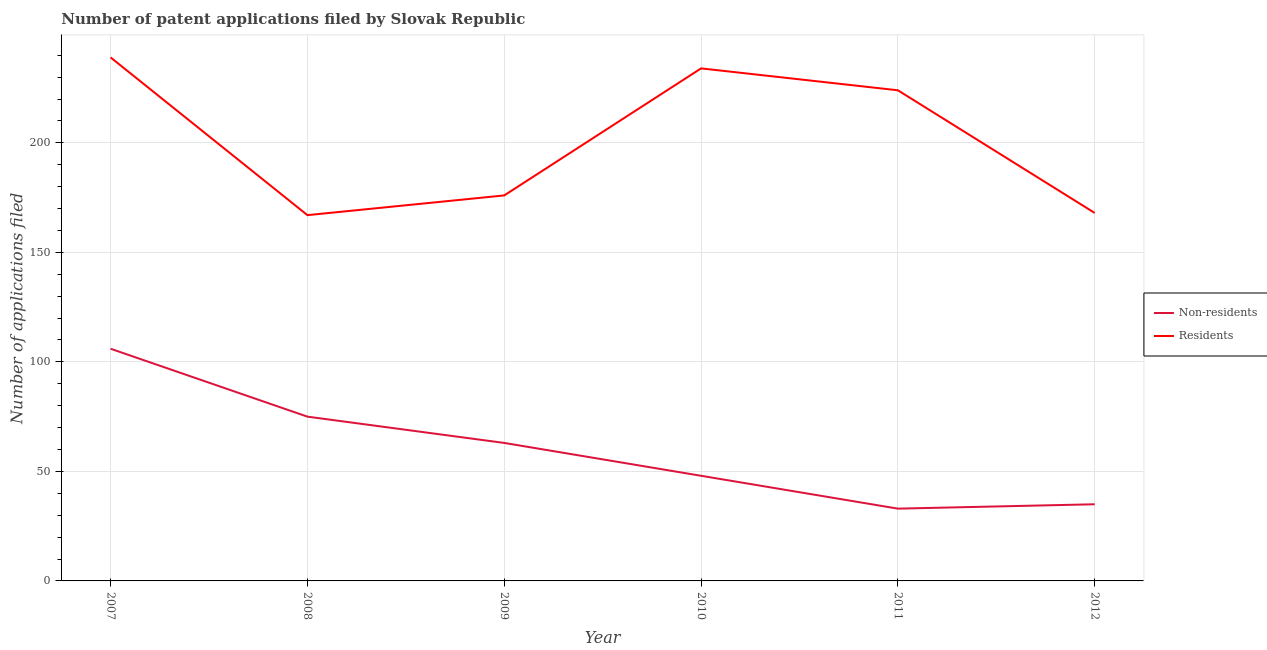Does the line corresponding to number of patent applications by non residents intersect with the line corresponding to number of patent applications by residents?
Your answer should be very brief. No. What is the number of patent applications by non residents in 2010?
Keep it short and to the point. 48. Across all years, what is the maximum number of patent applications by non residents?
Your answer should be compact. 106. Across all years, what is the minimum number of patent applications by non residents?
Offer a terse response. 33. In which year was the number of patent applications by residents maximum?
Give a very brief answer. 2007. What is the total number of patent applications by non residents in the graph?
Your answer should be compact. 360. What is the difference between the number of patent applications by residents in 2008 and that in 2011?
Make the answer very short. -57. What is the difference between the number of patent applications by residents in 2008 and the number of patent applications by non residents in 2007?
Your response must be concise. 61. What is the average number of patent applications by residents per year?
Your answer should be compact. 201.33. In the year 2007, what is the difference between the number of patent applications by non residents and number of patent applications by residents?
Ensure brevity in your answer.  -133. In how many years, is the number of patent applications by non residents greater than 30?
Offer a terse response. 6. What is the ratio of the number of patent applications by residents in 2009 to that in 2011?
Make the answer very short. 0.79. Is the number of patent applications by residents in 2010 less than that in 2011?
Your answer should be very brief. No. Is the difference between the number of patent applications by residents in 2011 and 2012 greater than the difference between the number of patent applications by non residents in 2011 and 2012?
Ensure brevity in your answer.  Yes. What is the difference between the highest and the lowest number of patent applications by non residents?
Give a very brief answer. 73. In how many years, is the number of patent applications by non residents greater than the average number of patent applications by non residents taken over all years?
Offer a very short reply. 3. Is the sum of the number of patent applications by residents in 2007 and 2008 greater than the maximum number of patent applications by non residents across all years?
Provide a succinct answer. Yes. How many lines are there?
Offer a terse response. 2. How many years are there in the graph?
Your response must be concise. 6. What is the difference between two consecutive major ticks on the Y-axis?
Make the answer very short. 50. Does the graph contain any zero values?
Your answer should be compact. No. Does the graph contain grids?
Offer a terse response. Yes. How are the legend labels stacked?
Offer a very short reply. Vertical. What is the title of the graph?
Make the answer very short. Number of patent applications filed by Slovak Republic. Does "Transport services" appear as one of the legend labels in the graph?
Offer a very short reply. No. What is the label or title of the X-axis?
Provide a succinct answer. Year. What is the label or title of the Y-axis?
Your answer should be compact. Number of applications filed. What is the Number of applications filed of Non-residents in 2007?
Your answer should be compact. 106. What is the Number of applications filed of Residents in 2007?
Provide a succinct answer. 239. What is the Number of applications filed in Residents in 2008?
Offer a terse response. 167. What is the Number of applications filed of Non-residents in 2009?
Make the answer very short. 63. What is the Number of applications filed of Residents in 2009?
Your response must be concise. 176. What is the Number of applications filed of Non-residents in 2010?
Your answer should be compact. 48. What is the Number of applications filed in Residents in 2010?
Ensure brevity in your answer.  234. What is the Number of applications filed in Residents in 2011?
Make the answer very short. 224. What is the Number of applications filed in Non-residents in 2012?
Give a very brief answer. 35. What is the Number of applications filed of Residents in 2012?
Ensure brevity in your answer.  168. Across all years, what is the maximum Number of applications filed of Non-residents?
Your answer should be very brief. 106. Across all years, what is the maximum Number of applications filed in Residents?
Make the answer very short. 239. Across all years, what is the minimum Number of applications filed of Residents?
Offer a terse response. 167. What is the total Number of applications filed in Non-residents in the graph?
Give a very brief answer. 360. What is the total Number of applications filed of Residents in the graph?
Offer a very short reply. 1208. What is the difference between the Number of applications filed in Residents in 2007 and that in 2008?
Provide a short and direct response. 72. What is the difference between the Number of applications filed of Residents in 2007 and that in 2009?
Give a very brief answer. 63. What is the difference between the Number of applications filed of Non-residents in 2007 and that in 2012?
Offer a very short reply. 71. What is the difference between the Number of applications filed in Residents in 2007 and that in 2012?
Ensure brevity in your answer.  71. What is the difference between the Number of applications filed in Non-residents in 2008 and that in 2009?
Give a very brief answer. 12. What is the difference between the Number of applications filed of Residents in 2008 and that in 2010?
Make the answer very short. -67. What is the difference between the Number of applications filed of Non-residents in 2008 and that in 2011?
Your response must be concise. 42. What is the difference between the Number of applications filed in Residents in 2008 and that in 2011?
Offer a terse response. -57. What is the difference between the Number of applications filed of Residents in 2009 and that in 2010?
Offer a very short reply. -58. What is the difference between the Number of applications filed in Residents in 2009 and that in 2011?
Ensure brevity in your answer.  -48. What is the difference between the Number of applications filed in Residents in 2010 and that in 2011?
Keep it short and to the point. 10. What is the difference between the Number of applications filed in Non-residents in 2011 and that in 2012?
Offer a terse response. -2. What is the difference between the Number of applications filed of Residents in 2011 and that in 2012?
Ensure brevity in your answer.  56. What is the difference between the Number of applications filed of Non-residents in 2007 and the Number of applications filed of Residents in 2008?
Your answer should be compact. -61. What is the difference between the Number of applications filed of Non-residents in 2007 and the Number of applications filed of Residents in 2009?
Provide a succinct answer. -70. What is the difference between the Number of applications filed in Non-residents in 2007 and the Number of applications filed in Residents in 2010?
Provide a short and direct response. -128. What is the difference between the Number of applications filed of Non-residents in 2007 and the Number of applications filed of Residents in 2011?
Give a very brief answer. -118. What is the difference between the Number of applications filed in Non-residents in 2007 and the Number of applications filed in Residents in 2012?
Your answer should be compact. -62. What is the difference between the Number of applications filed in Non-residents in 2008 and the Number of applications filed in Residents in 2009?
Your answer should be compact. -101. What is the difference between the Number of applications filed of Non-residents in 2008 and the Number of applications filed of Residents in 2010?
Offer a terse response. -159. What is the difference between the Number of applications filed in Non-residents in 2008 and the Number of applications filed in Residents in 2011?
Your answer should be compact. -149. What is the difference between the Number of applications filed of Non-residents in 2008 and the Number of applications filed of Residents in 2012?
Offer a very short reply. -93. What is the difference between the Number of applications filed of Non-residents in 2009 and the Number of applications filed of Residents in 2010?
Give a very brief answer. -171. What is the difference between the Number of applications filed of Non-residents in 2009 and the Number of applications filed of Residents in 2011?
Offer a terse response. -161. What is the difference between the Number of applications filed in Non-residents in 2009 and the Number of applications filed in Residents in 2012?
Ensure brevity in your answer.  -105. What is the difference between the Number of applications filed of Non-residents in 2010 and the Number of applications filed of Residents in 2011?
Provide a short and direct response. -176. What is the difference between the Number of applications filed in Non-residents in 2010 and the Number of applications filed in Residents in 2012?
Give a very brief answer. -120. What is the difference between the Number of applications filed in Non-residents in 2011 and the Number of applications filed in Residents in 2012?
Offer a very short reply. -135. What is the average Number of applications filed in Residents per year?
Ensure brevity in your answer.  201.33. In the year 2007, what is the difference between the Number of applications filed of Non-residents and Number of applications filed of Residents?
Provide a short and direct response. -133. In the year 2008, what is the difference between the Number of applications filed of Non-residents and Number of applications filed of Residents?
Your response must be concise. -92. In the year 2009, what is the difference between the Number of applications filed in Non-residents and Number of applications filed in Residents?
Your answer should be very brief. -113. In the year 2010, what is the difference between the Number of applications filed of Non-residents and Number of applications filed of Residents?
Your response must be concise. -186. In the year 2011, what is the difference between the Number of applications filed in Non-residents and Number of applications filed in Residents?
Offer a very short reply. -191. In the year 2012, what is the difference between the Number of applications filed of Non-residents and Number of applications filed of Residents?
Provide a succinct answer. -133. What is the ratio of the Number of applications filed of Non-residents in 2007 to that in 2008?
Make the answer very short. 1.41. What is the ratio of the Number of applications filed in Residents in 2007 to that in 2008?
Offer a terse response. 1.43. What is the ratio of the Number of applications filed of Non-residents in 2007 to that in 2009?
Make the answer very short. 1.68. What is the ratio of the Number of applications filed of Residents in 2007 to that in 2009?
Give a very brief answer. 1.36. What is the ratio of the Number of applications filed in Non-residents in 2007 to that in 2010?
Provide a succinct answer. 2.21. What is the ratio of the Number of applications filed of Residents in 2007 to that in 2010?
Keep it short and to the point. 1.02. What is the ratio of the Number of applications filed in Non-residents in 2007 to that in 2011?
Your answer should be compact. 3.21. What is the ratio of the Number of applications filed of Residents in 2007 to that in 2011?
Provide a succinct answer. 1.07. What is the ratio of the Number of applications filed in Non-residents in 2007 to that in 2012?
Offer a very short reply. 3.03. What is the ratio of the Number of applications filed in Residents in 2007 to that in 2012?
Give a very brief answer. 1.42. What is the ratio of the Number of applications filed in Non-residents in 2008 to that in 2009?
Offer a terse response. 1.19. What is the ratio of the Number of applications filed of Residents in 2008 to that in 2009?
Offer a terse response. 0.95. What is the ratio of the Number of applications filed of Non-residents in 2008 to that in 2010?
Your response must be concise. 1.56. What is the ratio of the Number of applications filed in Residents in 2008 to that in 2010?
Make the answer very short. 0.71. What is the ratio of the Number of applications filed in Non-residents in 2008 to that in 2011?
Provide a succinct answer. 2.27. What is the ratio of the Number of applications filed of Residents in 2008 to that in 2011?
Make the answer very short. 0.75. What is the ratio of the Number of applications filed in Non-residents in 2008 to that in 2012?
Your answer should be compact. 2.14. What is the ratio of the Number of applications filed in Residents in 2008 to that in 2012?
Your answer should be compact. 0.99. What is the ratio of the Number of applications filed in Non-residents in 2009 to that in 2010?
Your answer should be compact. 1.31. What is the ratio of the Number of applications filed in Residents in 2009 to that in 2010?
Provide a short and direct response. 0.75. What is the ratio of the Number of applications filed of Non-residents in 2009 to that in 2011?
Keep it short and to the point. 1.91. What is the ratio of the Number of applications filed of Residents in 2009 to that in 2011?
Keep it short and to the point. 0.79. What is the ratio of the Number of applications filed of Non-residents in 2009 to that in 2012?
Make the answer very short. 1.8. What is the ratio of the Number of applications filed in Residents in 2009 to that in 2012?
Your response must be concise. 1.05. What is the ratio of the Number of applications filed of Non-residents in 2010 to that in 2011?
Your answer should be very brief. 1.45. What is the ratio of the Number of applications filed of Residents in 2010 to that in 2011?
Ensure brevity in your answer.  1.04. What is the ratio of the Number of applications filed in Non-residents in 2010 to that in 2012?
Ensure brevity in your answer.  1.37. What is the ratio of the Number of applications filed of Residents in 2010 to that in 2012?
Ensure brevity in your answer.  1.39. What is the ratio of the Number of applications filed of Non-residents in 2011 to that in 2012?
Offer a terse response. 0.94. What is the difference between the highest and the lowest Number of applications filed in Residents?
Provide a short and direct response. 72. 